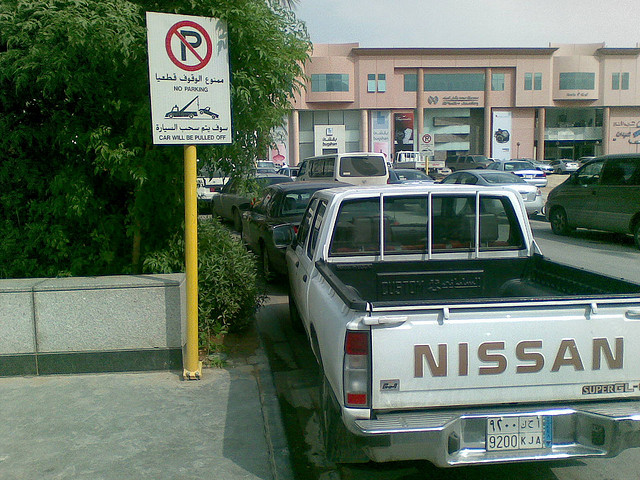Is this vehicle parked in compliance with the visible parking sign? No, the vehicle is parked directly under a 'No Parking' sign. The sign also indicates that violators risk having their cars towed. 